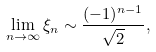<formula> <loc_0><loc_0><loc_500><loc_500>\lim _ { n \to \infty } \xi _ { n } \sim \frac { ( - 1 ) ^ { n - 1 } } { \sqrt { 2 } } ,</formula> 